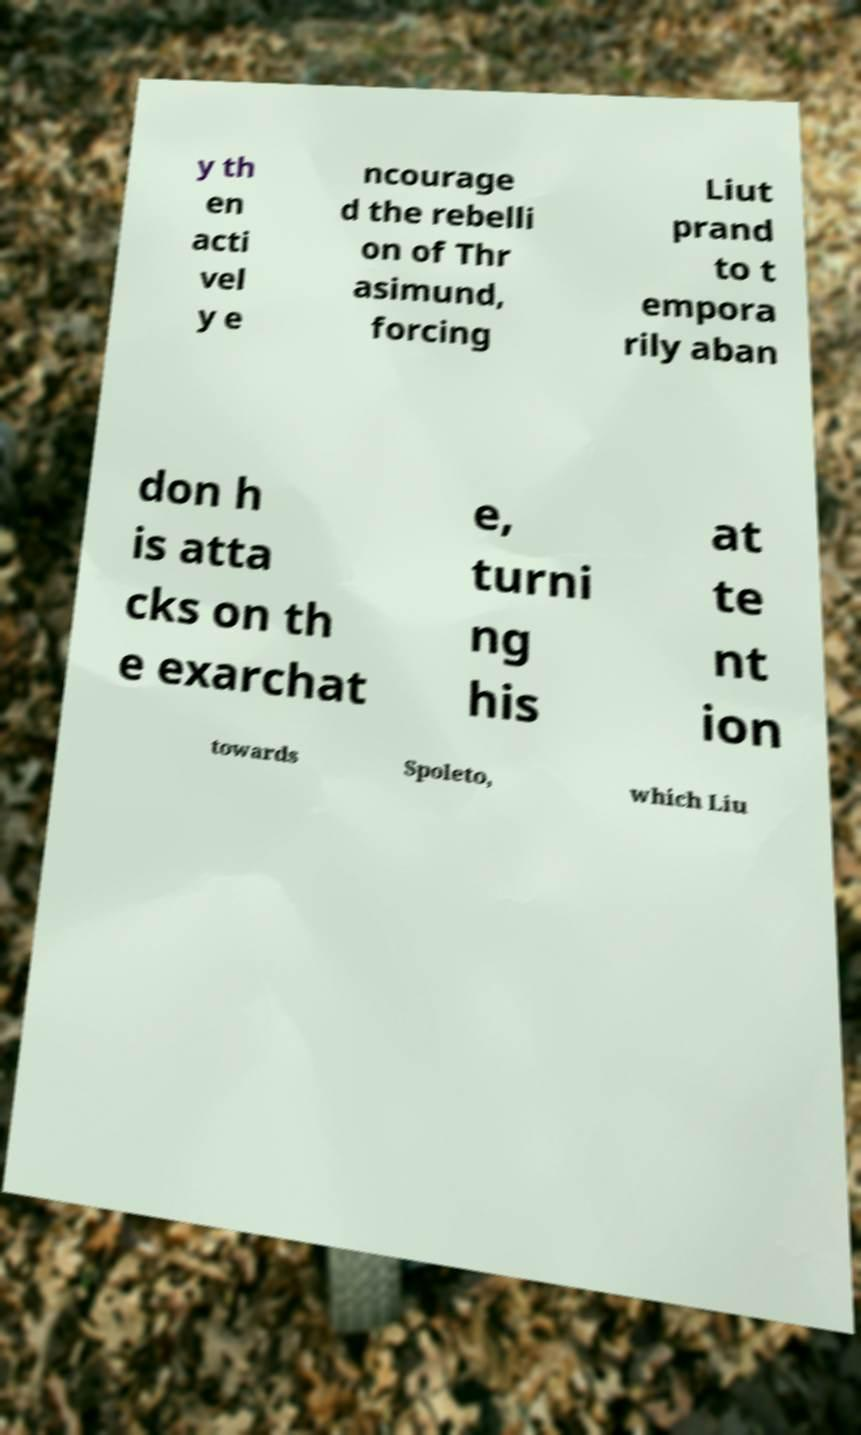Could you extract and type out the text from this image? y th en acti vel y e ncourage d the rebelli on of Thr asimund, forcing Liut prand to t empora rily aban don h is atta cks on th e exarchat e, turni ng his at te nt ion towards Spoleto, which Liu 